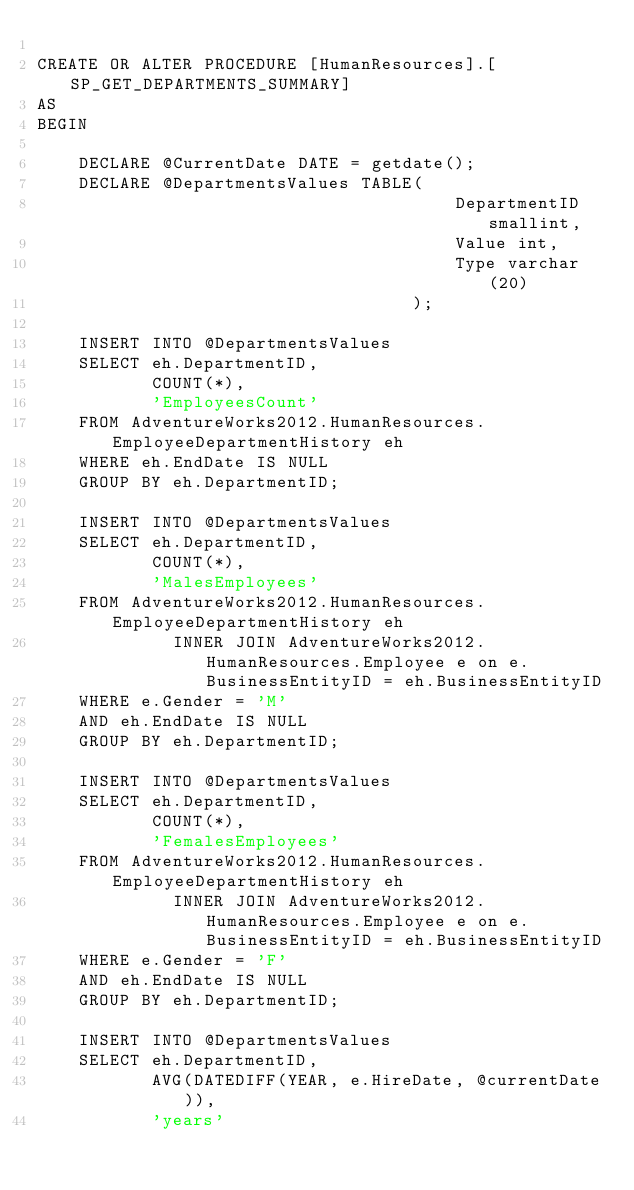Convert code to text. <code><loc_0><loc_0><loc_500><loc_500><_SQL_>
CREATE OR ALTER PROCEDURE [HumanResources].[SP_GET_DEPARTMENTS_SUMMARY]
AS
BEGIN

    DECLARE @CurrentDate DATE = getdate();
    DECLARE @DepartmentsValues TABLE(
                                        DepartmentID smallint,
                                        Value int,
                                        Type varchar(20)
                                    );

    INSERT INTO @DepartmentsValues
    SELECT eh.DepartmentID,
           COUNT(*),
           'EmployeesCount'
    FROM AdventureWorks2012.HumanResources.EmployeeDepartmentHistory eh
    WHERE eh.EndDate IS NULL
    GROUP BY eh.DepartmentID;

    INSERT INTO @DepartmentsValues
    SELECT eh.DepartmentID,
           COUNT(*),
           'MalesEmployees'
    FROM AdventureWorks2012.HumanResources.EmployeeDepartmentHistory eh
             INNER JOIN AdventureWorks2012.HumanResources.Employee e on e.BusinessEntityID = eh.BusinessEntityID
    WHERE e.Gender = 'M'
    AND eh.EndDate IS NULL
    GROUP BY eh.DepartmentID;

    INSERT INTO @DepartmentsValues
    SELECT eh.DepartmentID,
           COUNT(*),
           'FemalesEmployees'
    FROM AdventureWorks2012.HumanResources.EmployeeDepartmentHistory eh
             INNER JOIN AdventureWorks2012.HumanResources.Employee e on e.BusinessEntityID = eh.BusinessEntityID
    WHERE e.Gender = 'F'
    AND eh.EndDate IS NULL
    GROUP BY eh.DepartmentID;

    INSERT INTO @DepartmentsValues
    SELECT eh.DepartmentID,
           AVG(DATEDIFF(YEAR, e.HireDate, @currentDate)),
           'years'</code> 